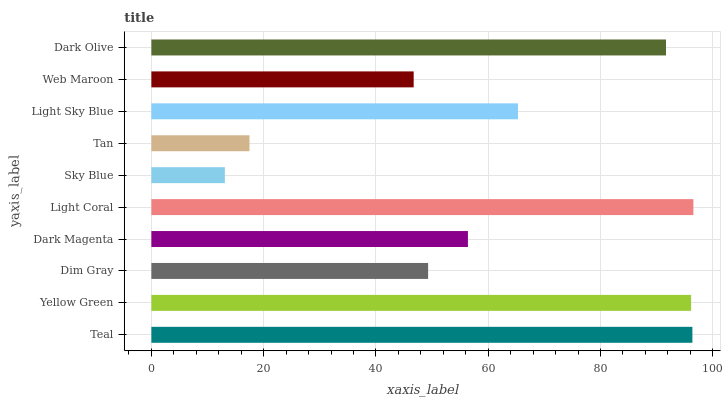Is Sky Blue the minimum?
Answer yes or no. Yes. Is Light Coral the maximum?
Answer yes or no. Yes. Is Yellow Green the minimum?
Answer yes or no. No. Is Yellow Green the maximum?
Answer yes or no. No. Is Teal greater than Yellow Green?
Answer yes or no. Yes. Is Yellow Green less than Teal?
Answer yes or no. Yes. Is Yellow Green greater than Teal?
Answer yes or no. No. Is Teal less than Yellow Green?
Answer yes or no. No. Is Light Sky Blue the high median?
Answer yes or no. Yes. Is Dark Magenta the low median?
Answer yes or no. Yes. Is Tan the high median?
Answer yes or no. No. Is Teal the low median?
Answer yes or no. No. 